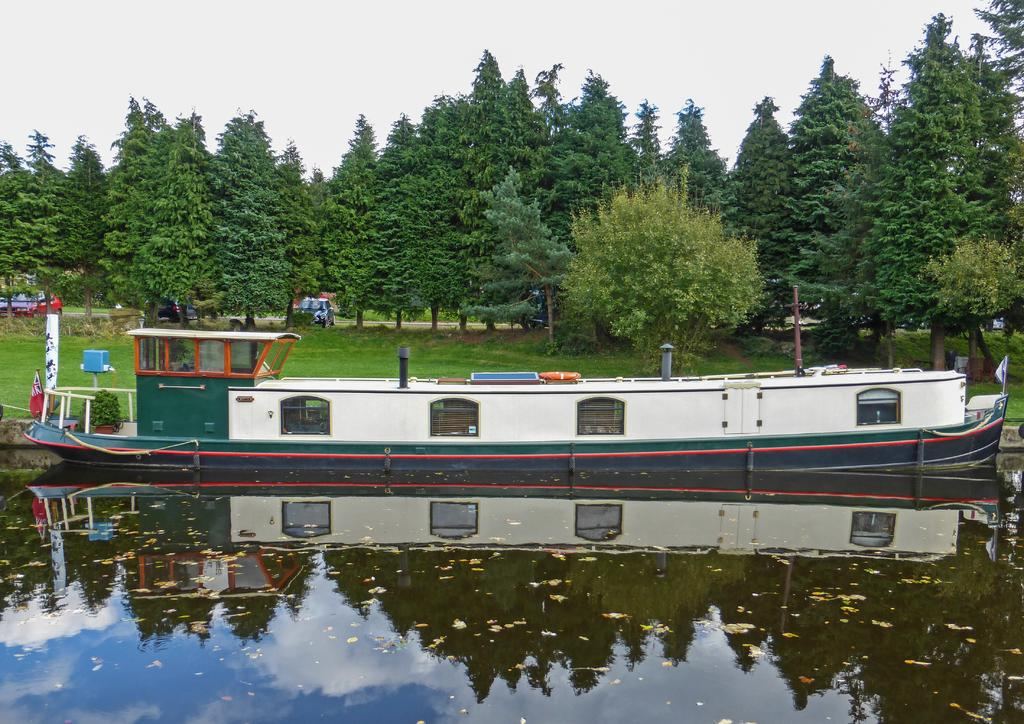What is the main subject of the image? The main subject of the image is a boat on water. What can be seen in the background of the image? Trees and the sky are visible in the background of the image. What else is present in the image besides the boat? There are vehicles on the road in the image. What type of appliance can be seen plugged into the boat in the image? There is no appliance visible in the image, and the boat is not shown to be plugged into anything. 